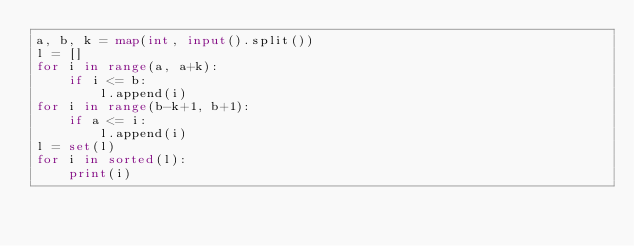<code> <loc_0><loc_0><loc_500><loc_500><_Python_>a, b, k = map(int, input().split())
l = []
for i in range(a, a+k):
    if i <= b:
        l.append(i)
for i in range(b-k+1, b+1):
    if a <= i:
        l.append(i)
l = set(l)
for i in sorted(l):
    print(i)</code> 